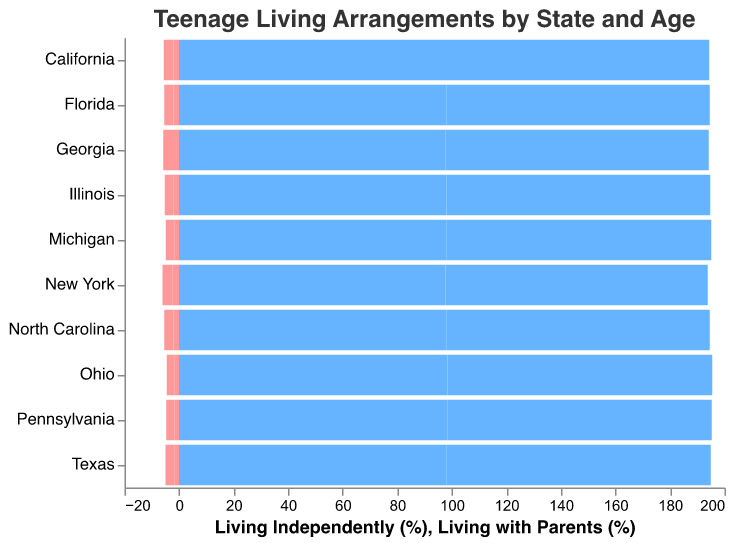What is the percentage of 17-year-old teenagers living independently in California? Look at the bar for 17-year-olds in California representing "Living Independently (%)". The tooltip or bar value should show 3.5%.
Answer: 3.5% Which age group (16 or 17) has a higher percentage of teenagers living independently in New York? Compare the bars for 16-year-olds and 17-year-olds in New York for "Living Independently (%)". The 17-year olds have 3.8%, while 16-year olds have 2.3%.
Answer: 17-year-olds What state has the lowest percentage of 16-year-olds living independently? Look at the bars for 16-year-olds across all states for "Living Independently (%)" and identify the lowest one. Ohio shows the lowest at 1.6%.
Answer: Ohio By how much does the percentage of 17-year-olds living independently in Texas differ from that in Pennsylvania? Subtract the "Living Independently (%)" value of Pennsylvania (3.0%) from Texas (3.2%). The difference is 0.2%.
Answer: 0.2% What is the total percentage of 16-year-olds living independently across Florida, Illinois, and Michigan? Sum the "Living Independently (%)" values for 16-year-olds in Florida, Illinois, and Michigan: 2.0% + 1.9% + 1.8% = 5.7%.
Answer: 5.7% Which state has a higher percentage of 17-year-olds living with parents, New York or Georgia? Compare the bars for 17-year-olds in New York and Georgia for "Living with Parents (%)". New York has 96.2%, and Georgia has 96.4%.
Answer: Georgia What is the difference in the percentage of 16-year-olds living independently between Texas and North Carolina? Subtract the "Living Independently (%)" value of Texas (1.8%) from North Carolina (2.0%). The difference is 0.2%.
Answer: 0.2% Which two states have very close percentages of 17-year-old teenagers living independently? Compare the "Living Independently (%)" values across all states for 17-year-olds. Illinois (3.3%) and Florida (3.4%) are very close.
Answer: Illinois and Florida What is the combined percentage of 17-year-olds living independently in California, Texas, and New York? Add the "Living Independently (%)" values for 17-year-olds in California (3.5%), Texas (3.2%), and New York (3.8%): 3.5% + 3.2% + 3.8% = 10.5%.
Answer: 10.5% 